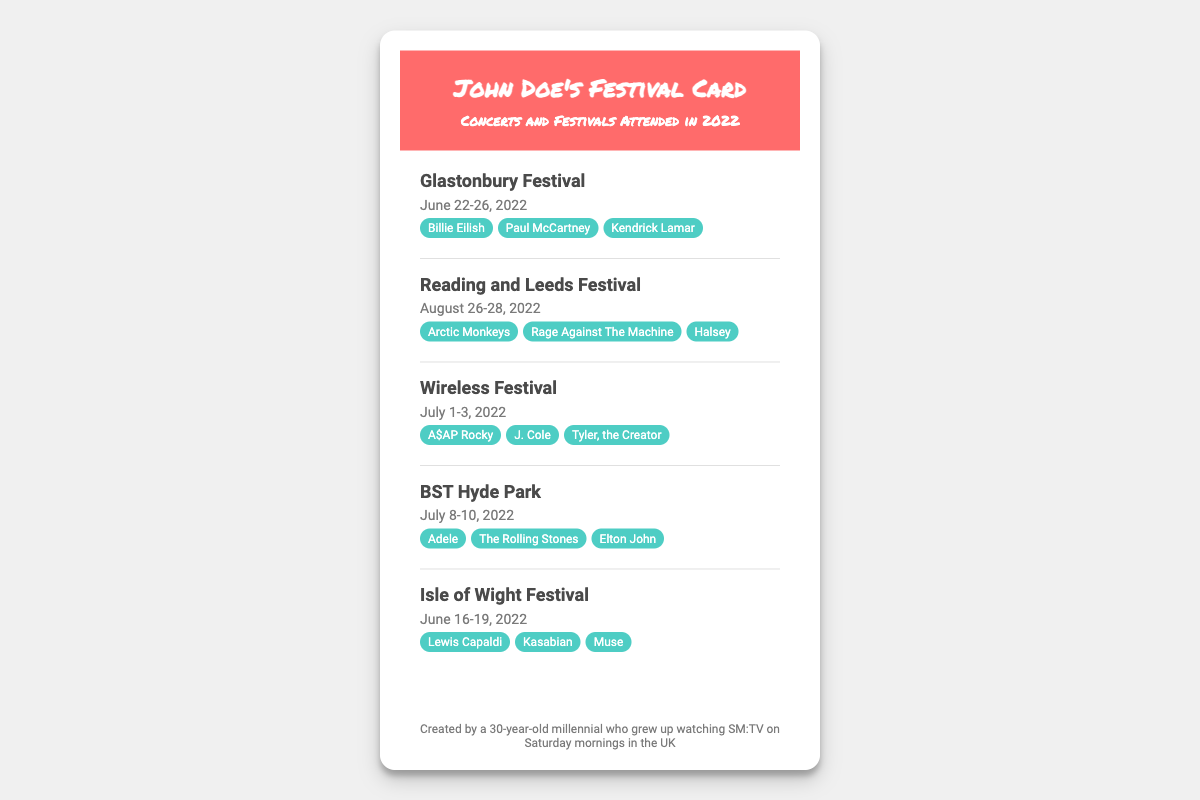What was the first festival attended? The document lists festivals in chronological order, with the Isle of Wight Festival on June 16-19, 2022 being the first mentioned.
Answer: Isle of Wight Festival Who headlined Glastonbury Festival? The headliners for Glastonbury Festival are listed below the event name, and include Billie Eilish, Paul McCartney, and Kendrick Lamar.
Answer: Billie Eilish, Paul McCartney, Kendrick Lamar How many days did the Wireless Festival last? The Wireless Festival is specified as taking place from July 1-3, 2022, which is a span of three days.
Answer: 3 days Which festival occurred in August? The Reading and Leeds Festival is the only festival listed that took place in August 2022.
Answer: Reading and Leeds Festival What is the unique feature of the footer? The footer contains a personal touch, indicating the creator's background and connection to a UK show, which gives context to the card.
Answer: Creator's background Which artist headlined BST Hyde Park? The document mentions three headliners for BST Hyde Park, with Adele being one of them.
Answer: Adele In what month did the Glastonbury Festival take place? The festival is scheduled from June 22-26, 2022, indicating it occurs in June.
Answer: June What are the festival dates for Reading and Leeds Festival? The document specifies the dates for this festival from August 26-28, 2022.
Answer: August 26-28, 2022 